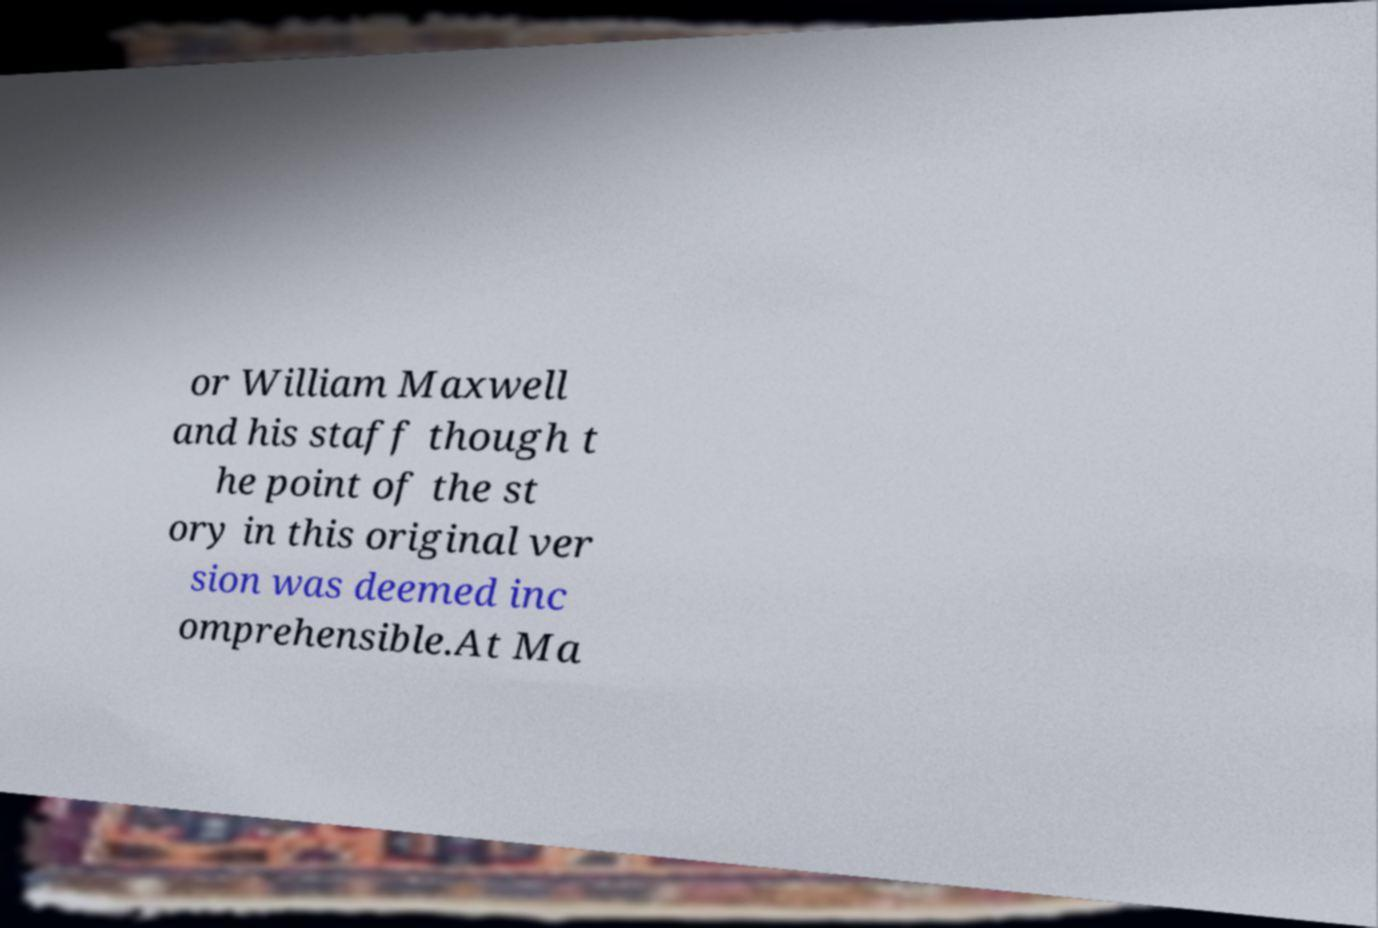Can you accurately transcribe the text from the provided image for me? or William Maxwell and his staff though t he point of the st ory in this original ver sion was deemed inc omprehensible.At Ma 